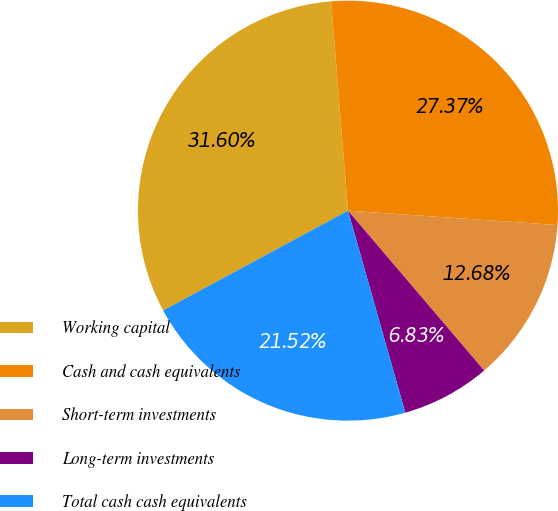Convert chart to OTSL. <chart><loc_0><loc_0><loc_500><loc_500><pie_chart><fcel>Working capital<fcel>Cash and cash equivalents<fcel>Short-term investments<fcel>Long-term investments<fcel>Total cash cash equivalents<nl><fcel>31.6%<fcel>27.37%<fcel>12.68%<fcel>6.83%<fcel>21.52%<nl></chart> 